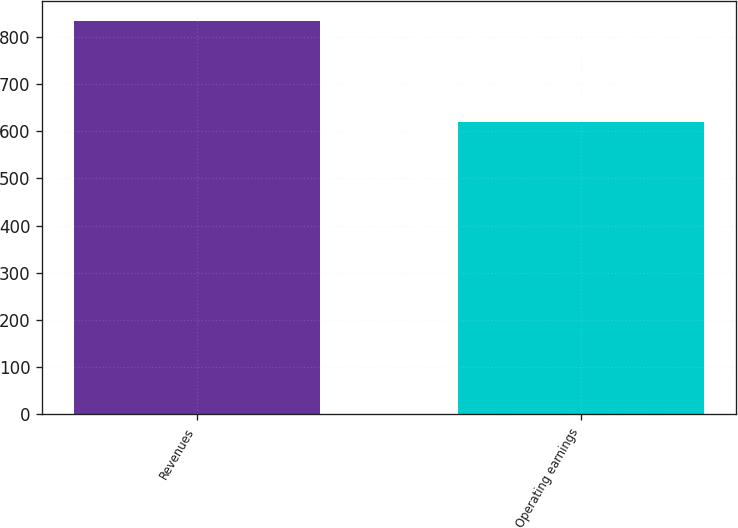Convert chart to OTSL. <chart><loc_0><loc_0><loc_500><loc_500><bar_chart><fcel>Revenues<fcel>Operating earnings<nl><fcel>835<fcel>620<nl></chart> 